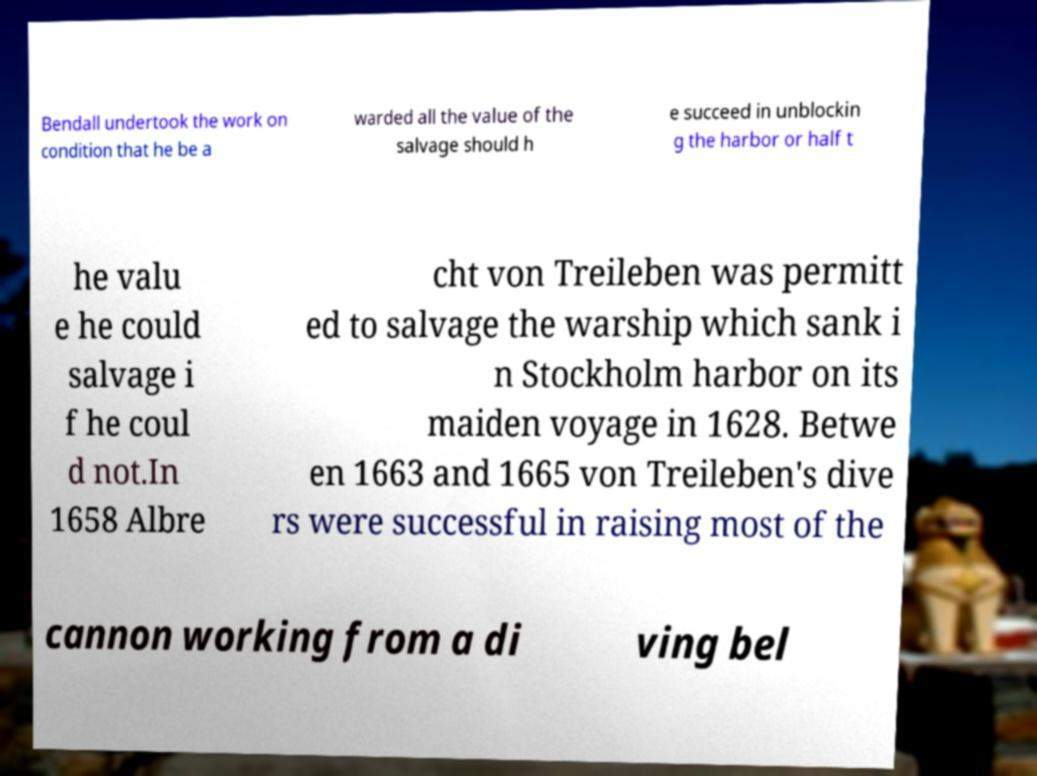Could you extract and type out the text from this image? Bendall undertook the work on condition that he be a warded all the value of the salvage should h e succeed in unblockin g the harbor or half t he valu e he could salvage i f he coul d not.In 1658 Albre cht von Treileben was permitt ed to salvage the warship which sank i n Stockholm harbor on its maiden voyage in 1628. Betwe en 1663 and 1665 von Treileben's dive rs were successful in raising most of the cannon working from a di ving bel 